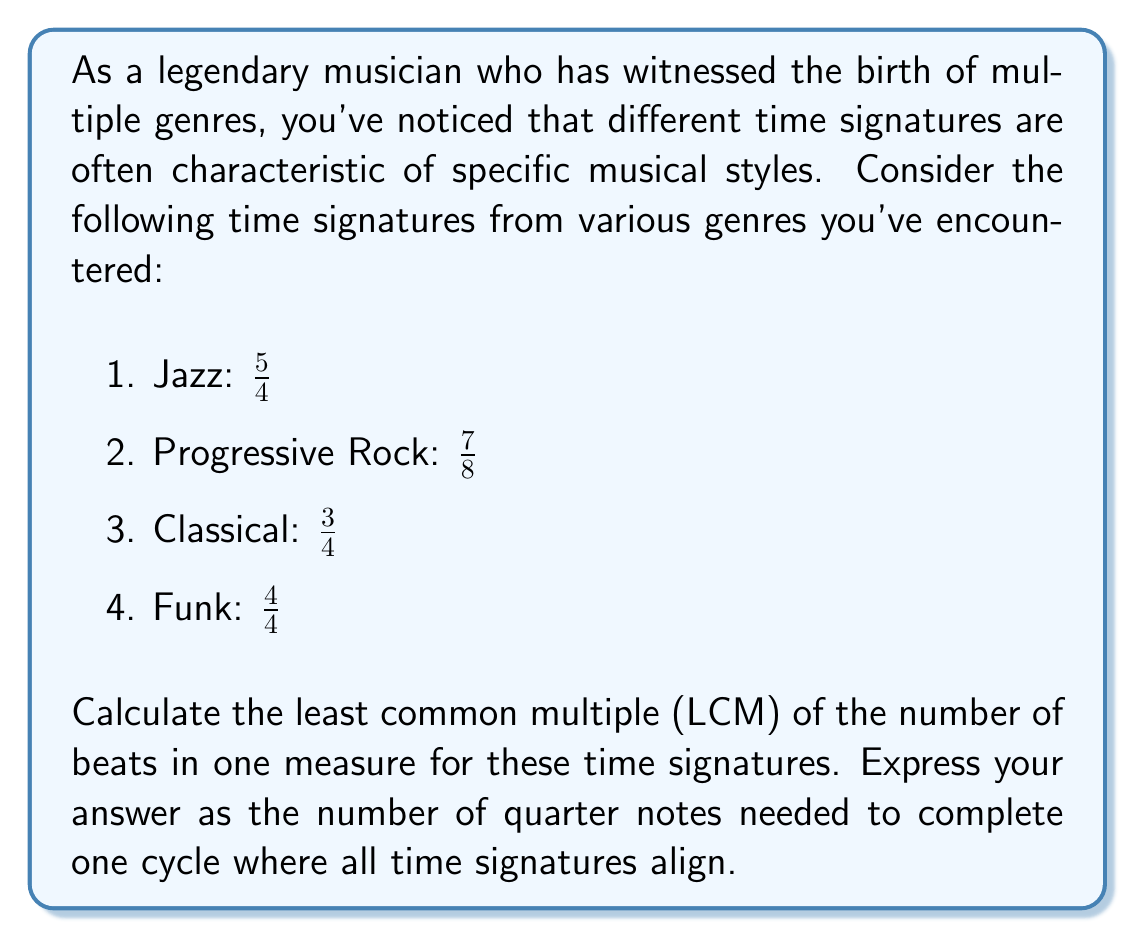Can you solve this math problem? To solve this problem, we need to follow these steps:

1. Convert all time signatures to a common denominator (quarter notes).
2. Find the numerators of each time signature.
3. Calculate the LCM of these numerators.

Step 1: Converting to quarter notes
- Jazz ($\frac{5}{4}$): Already in quarter notes
- Progressive Rock ($\frac{7}{8}$): Convert to $\frac{7}{2}$ quarter notes
- Classical ($\frac{3}{4}$): Already in quarter notes
- Funk ($\frac{4}{4}$): Already in quarter notes

Step 2: Numerators
- Jazz: 5
- Progressive Rock: 7/2 = 3.5 (we'll use 7 half notes)
- Classical: 3
- Funk: 4

Step 3: Calculate LCM
We need to find LCM(5, 7, 3, 4)

First, let's find the prime factorization of each number:
- 5 = 5
- 7 = 7
- 3 = 3
- 4 = 2^2

The LCM will include the highest power of each prime factor:

$$ LCM = 2^2 \times 3 \times 5 \times 7 = 420 $$

This result is in half notes for the Progressive Rock time signature. To convert to quarter notes, we multiply by 2:

$$ 420 \times 2 = 840 $$

Therefore, it will take 840 quarter notes for all these time signatures to align and complete one cycle.
Answer: 840 quarter notes 